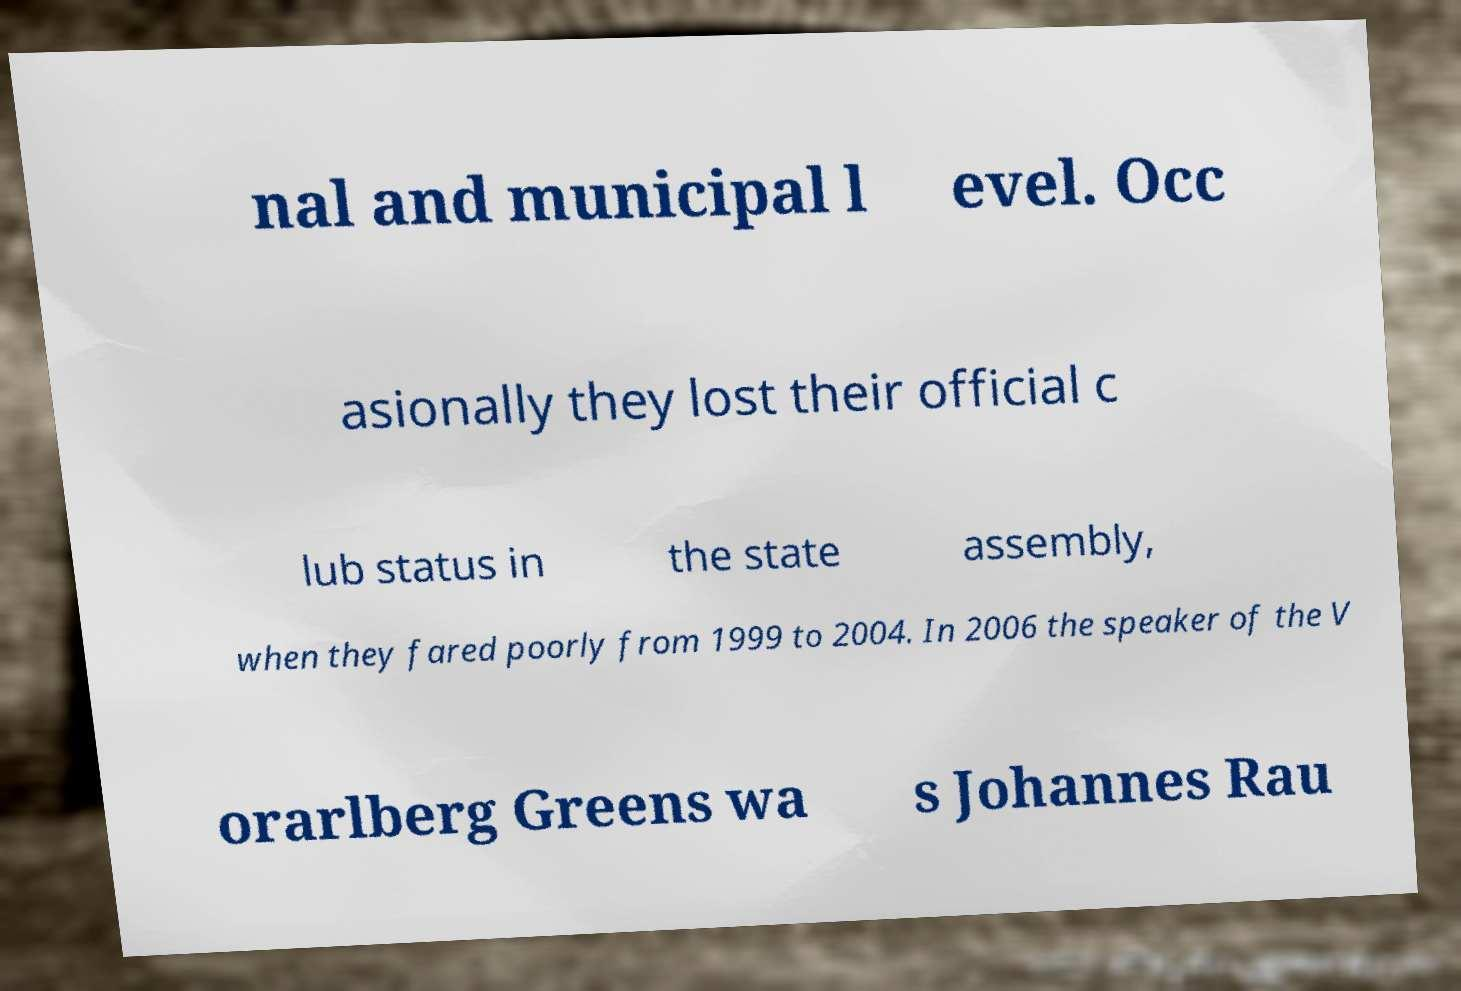I need the written content from this picture converted into text. Can you do that? nal and municipal l evel. Occ asionally they lost their official c lub status in the state assembly, when they fared poorly from 1999 to 2004. In 2006 the speaker of the V orarlberg Greens wa s Johannes Rau 